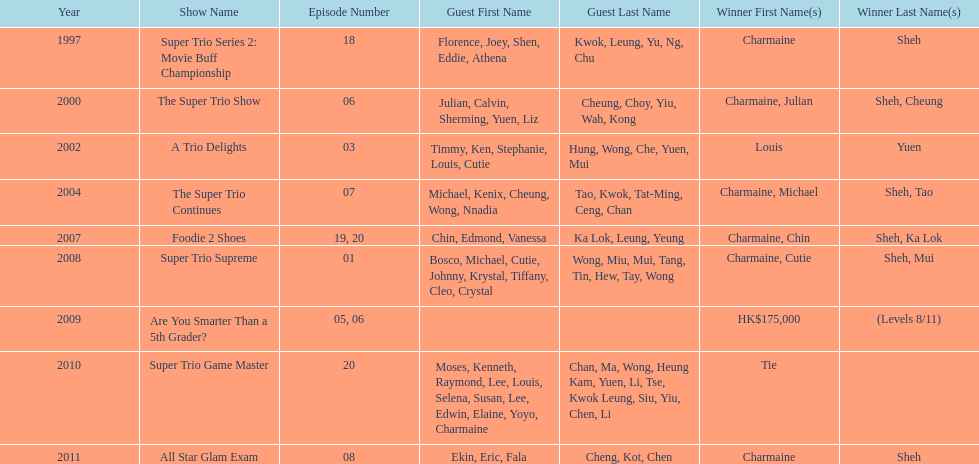What is the number of tv shows that charmaine sheh has appeared on? 9. 